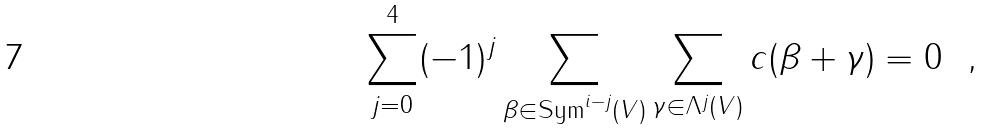Convert formula to latex. <formula><loc_0><loc_0><loc_500><loc_500>\sum _ { j = 0 } ^ { 4 } ( - 1 ) ^ { j } \sum _ { \beta \in \text {Sym} ^ { i - j } ( V ) } \sum _ { \gamma \in \Lambda ^ { j } ( V ) } c ( \beta + \gamma ) = 0 \ \ ,</formula> 